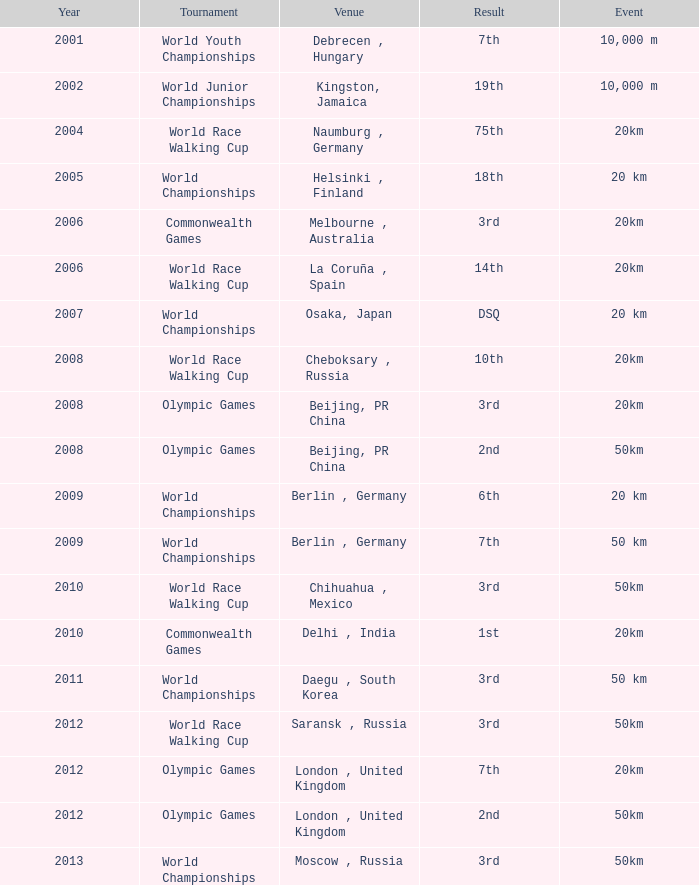What is the conclusion of the world race walking cup event conducted before 2010? 3rd. Could you help me parse every detail presented in this table? {'header': ['Year', 'Tournament', 'Venue', 'Result', 'Event'], 'rows': [['2001', 'World Youth Championships', 'Debrecen , Hungary', '7th', '10,000 m'], ['2002', 'World Junior Championships', 'Kingston, Jamaica', '19th', '10,000 m'], ['2004', 'World Race Walking Cup', 'Naumburg , Germany', '75th', '20km'], ['2005', 'World Championships', 'Helsinki , Finland', '18th', '20 km'], ['2006', 'Commonwealth Games', 'Melbourne , Australia', '3rd', '20km'], ['2006', 'World Race Walking Cup', 'La Coruña , Spain', '14th', '20km'], ['2007', 'World Championships', 'Osaka, Japan', 'DSQ', '20 km'], ['2008', 'World Race Walking Cup', 'Cheboksary , Russia', '10th', '20km'], ['2008', 'Olympic Games', 'Beijing, PR China', '3rd', '20km'], ['2008', 'Olympic Games', 'Beijing, PR China', '2nd', '50km'], ['2009', 'World Championships', 'Berlin , Germany', '6th', '20 km'], ['2009', 'World Championships', 'Berlin , Germany', '7th', '50 km'], ['2010', 'World Race Walking Cup', 'Chihuahua , Mexico', '3rd', '50km'], ['2010', 'Commonwealth Games', 'Delhi , India', '1st', '20km'], ['2011', 'World Championships', 'Daegu , South Korea', '3rd', '50 km'], ['2012', 'World Race Walking Cup', 'Saransk , Russia', '3rd', '50km'], ['2012', 'Olympic Games', 'London , United Kingdom', '7th', '20km'], ['2012', 'Olympic Games', 'London , United Kingdom', '2nd', '50km'], ['2013', 'World Championships', 'Moscow , Russia', '3rd', '50km']]} 